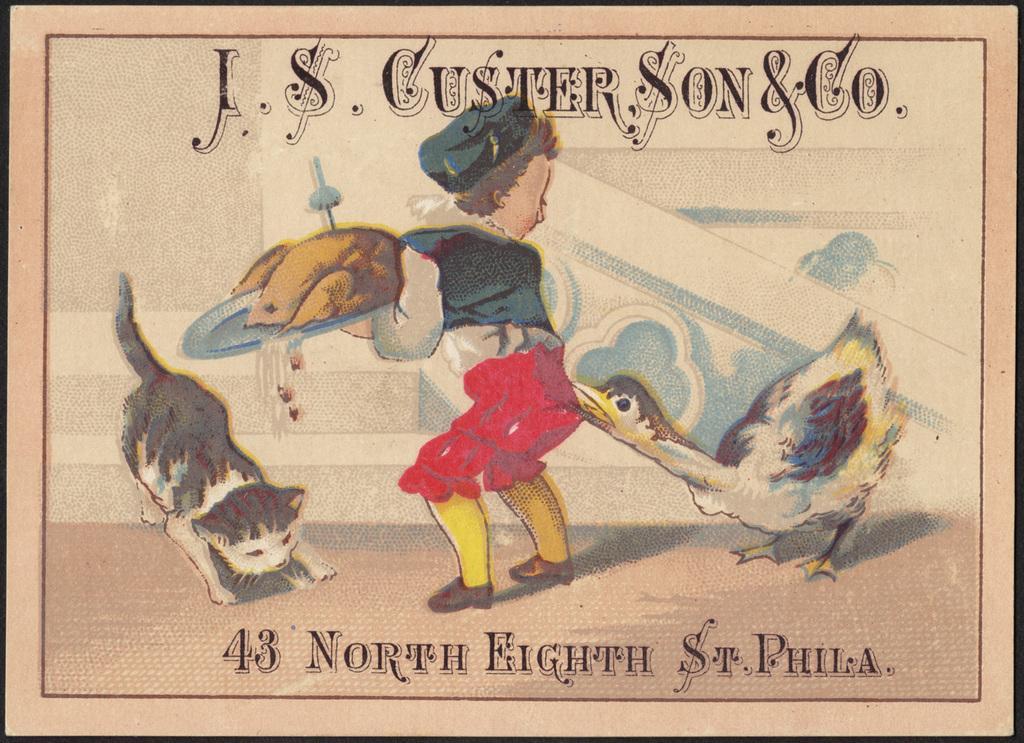Describe this image in one or two sentences. Here in this picture we can see a poster, on which we can see a woman holding a plate in her hand and we can also see a bird and a cat present and we can also see some text present. 